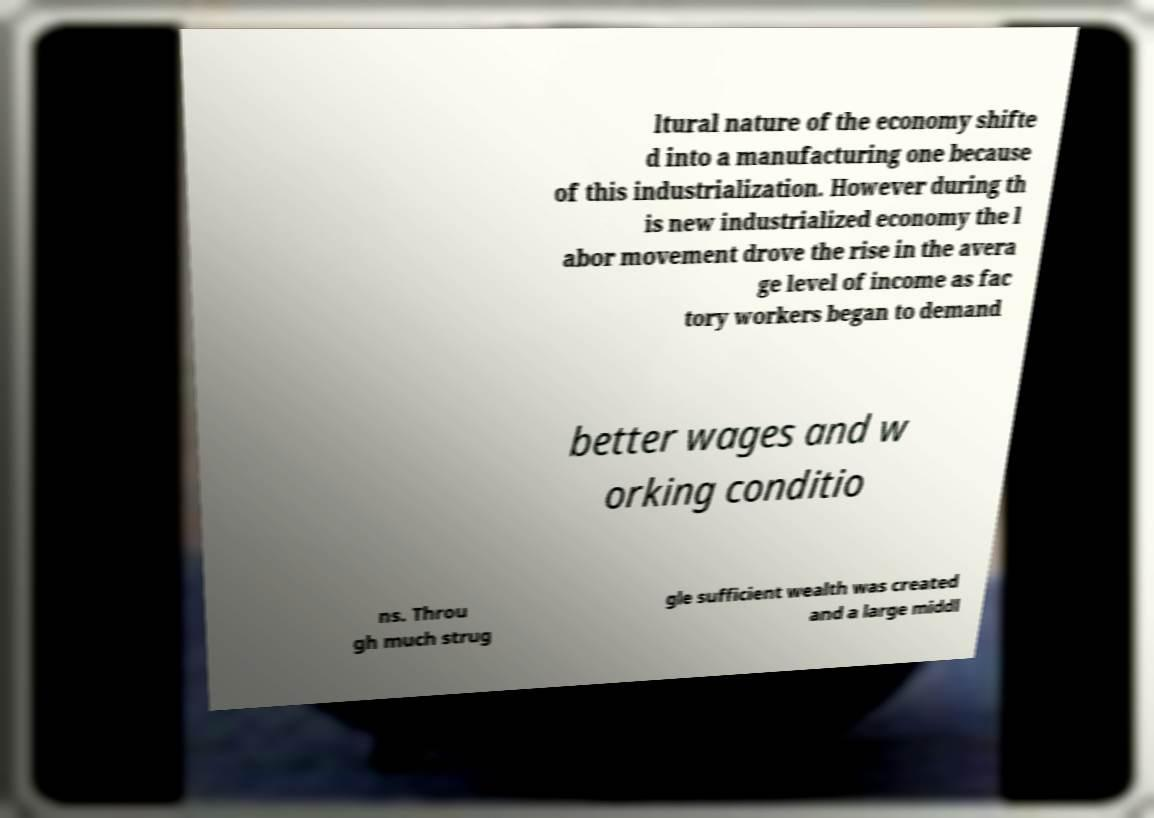I need the written content from this picture converted into text. Can you do that? ltural nature of the economy shifte d into a manufacturing one because of this industrialization. However during th is new industrialized economy the l abor movement drove the rise in the avera ge level of income as fac tory workers began to demand better wages and w orking conditio ns. Throu gh much strug gle sufficient wealth was created and a large middl 